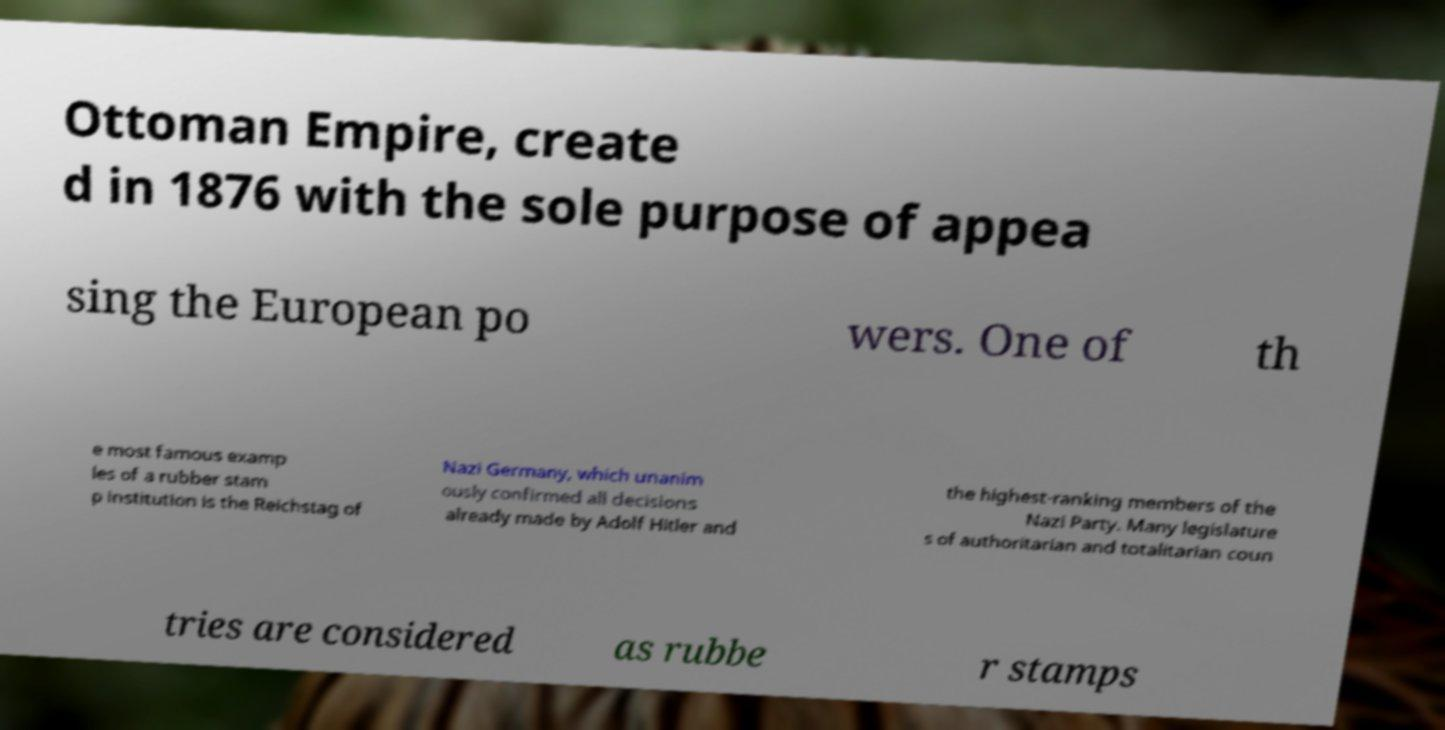Please identify and transcribe the text found in this image. Ottoman Empire, create d in 1876 with the sole purpose of appea sing the European po wers. One of th e most famous examp les of a rubber stam p institution is the Reichstag of Nazi Germany, which unanim ously confirmed all decisions already made by Adolf Hitler and the highest-ranking members of the Nazi Party. Many legislature s of authoritarian and totalitarian coun tries are considered as rubbe r stamps 